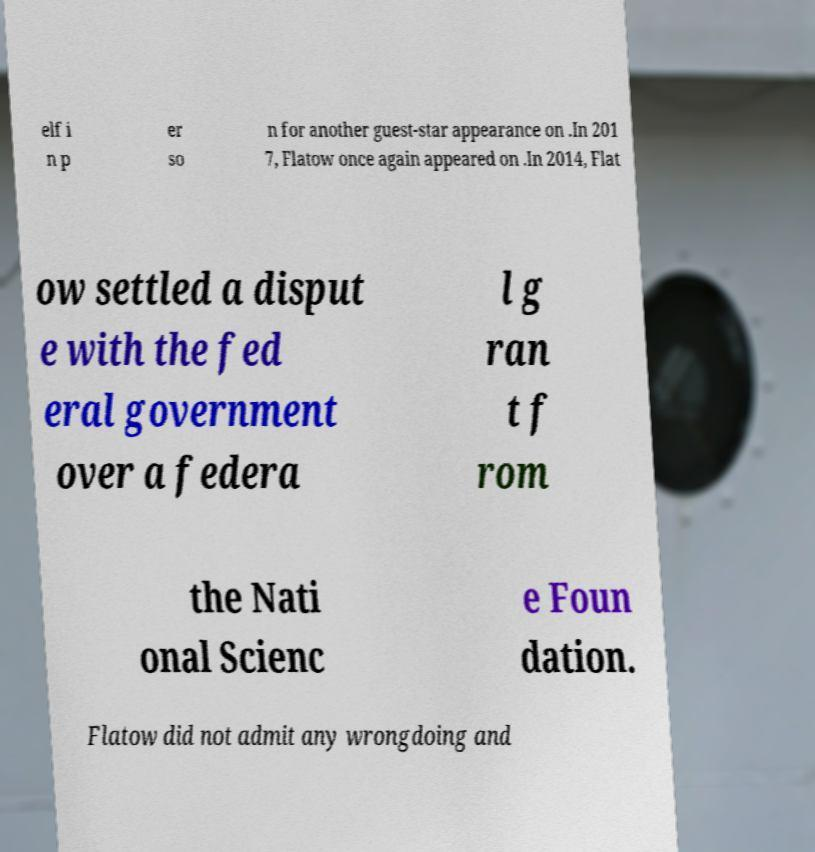What messages or text are displayed in this image? I need them in a readable, typed format. elf i n p er so n for another guest-star appearance on .In 201 7, Flatow once again appeared on .In 2014, Flat ow settled a disput e with the fed eral government over a federa l g ran t f rom the Nati onal Scienc e Foun dation. Flatow did not admit any wrongdoing and 